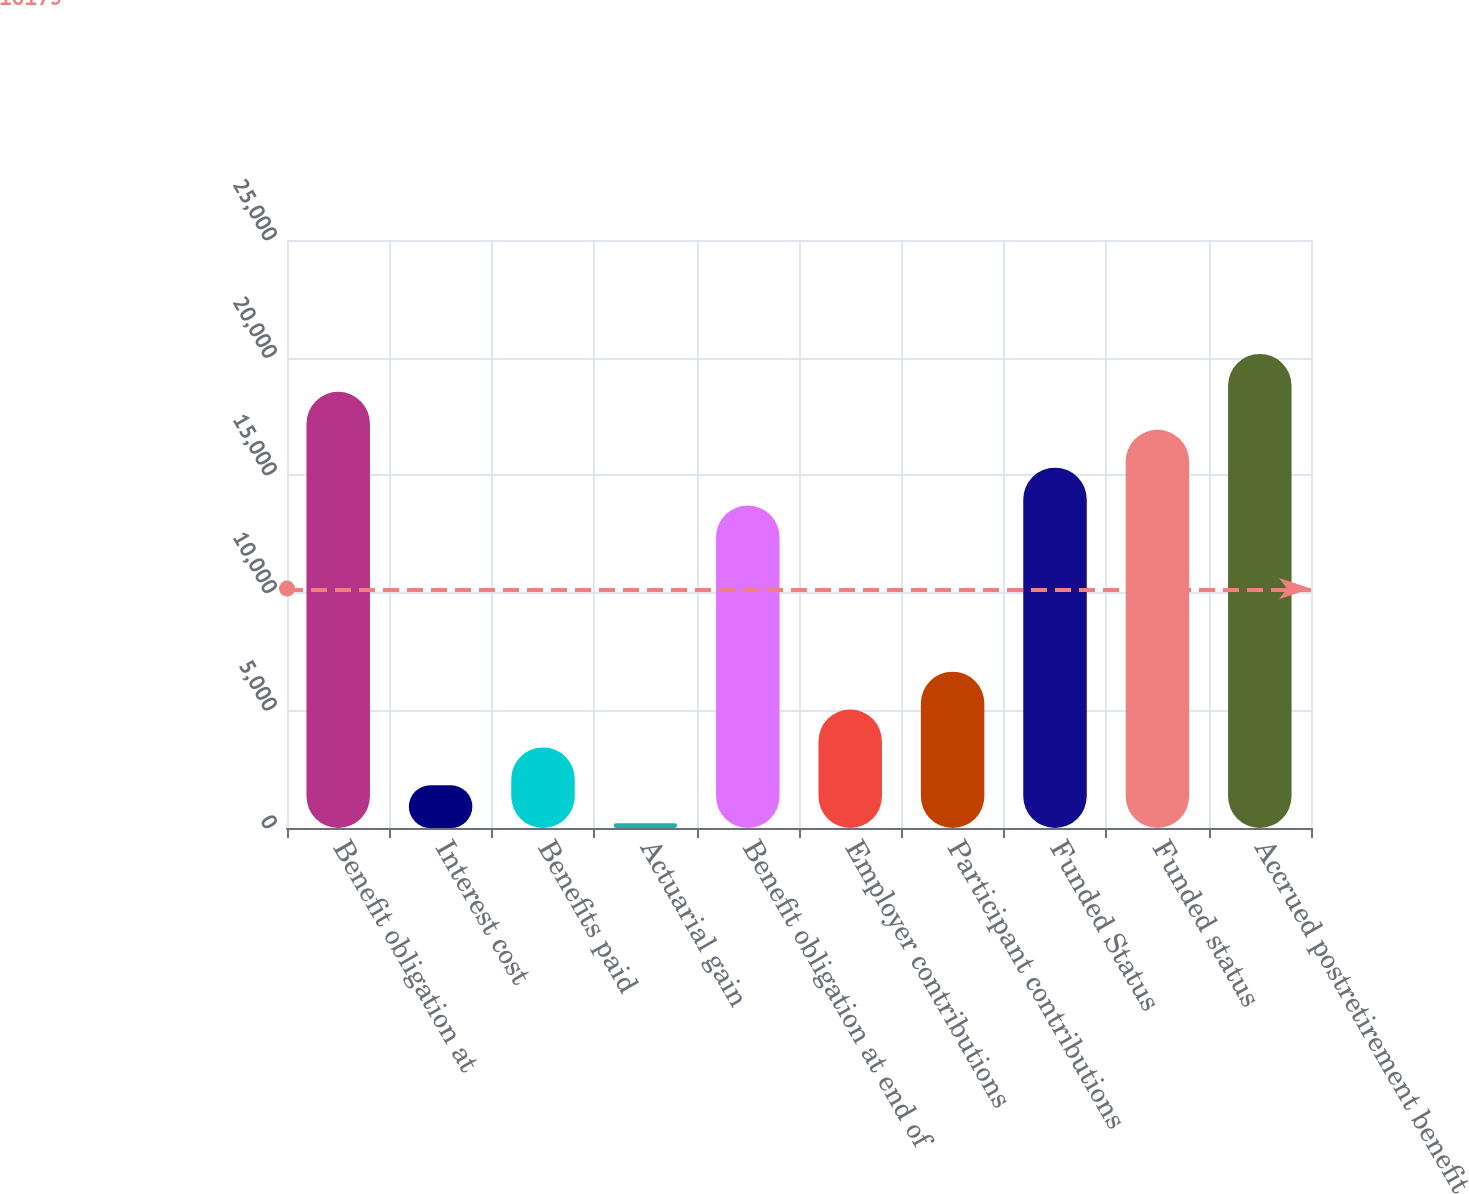<chart> <loc_0><loc_0><loc_500><loc_500><bar_chart><fcel>Benefit obligation at<fcel>Interest cost<fcel>Benefits paid<fcel>Actuarial gain<fcel>Benefit obligation at end of<fcel>Employer contributions<fcel>Participant contributions<fcel>Funded Status<fcel>Funded status<fcel>Accrued postretirement benefit<nl><fcel>18544<fcel>1814<fcel>3425<fcel>203<fcel>13711<fcel>5036<fcel>6647<fcel>15322<fcel>16933<fcel>20155<nl></chart> 